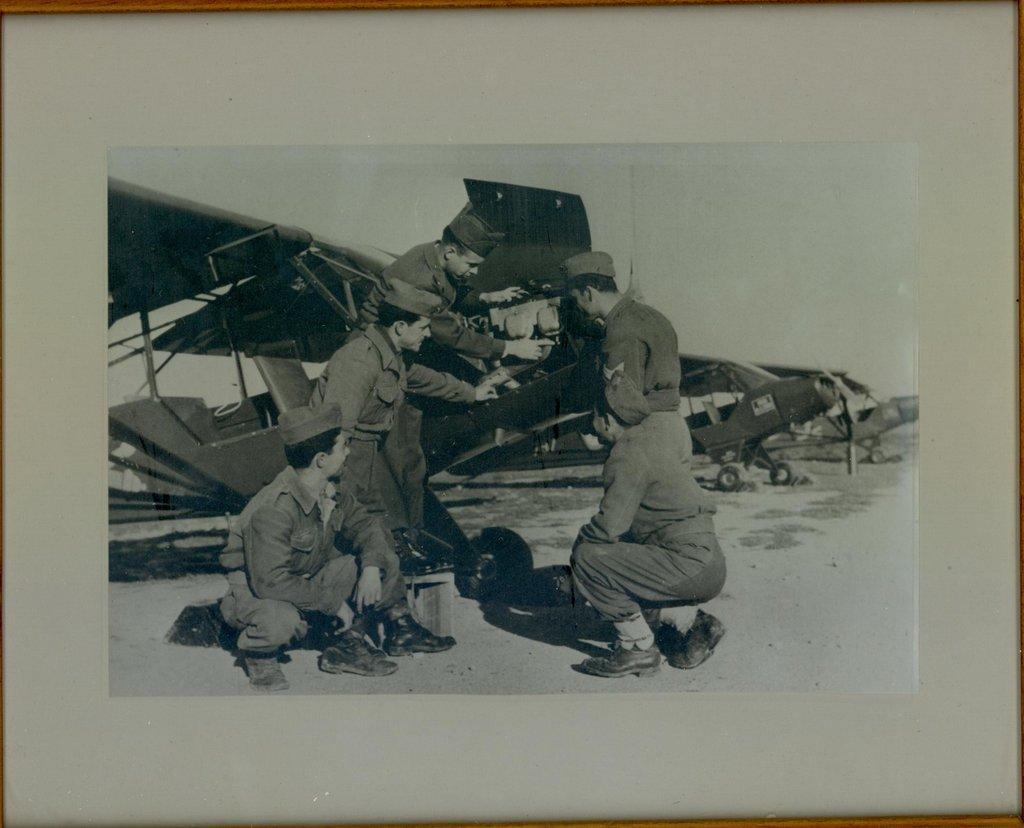How would you summarize this image in a sentence or two? In this image we can see a photo frame, in the photo frame we can see a few people, airplanes and other objects. 